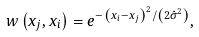Convert formula to latex. <formula><loc_0><loc_0><loc_500><loc_500>w \left ( x _ { j } , x _ { i } \right ) = e ^ { - \left ( x _ { i } - x _ { j } \right ) ^ { 2 } / \left ( 2 \hat { \sigma } ^ { 2 } \right ) } ,</formula> 